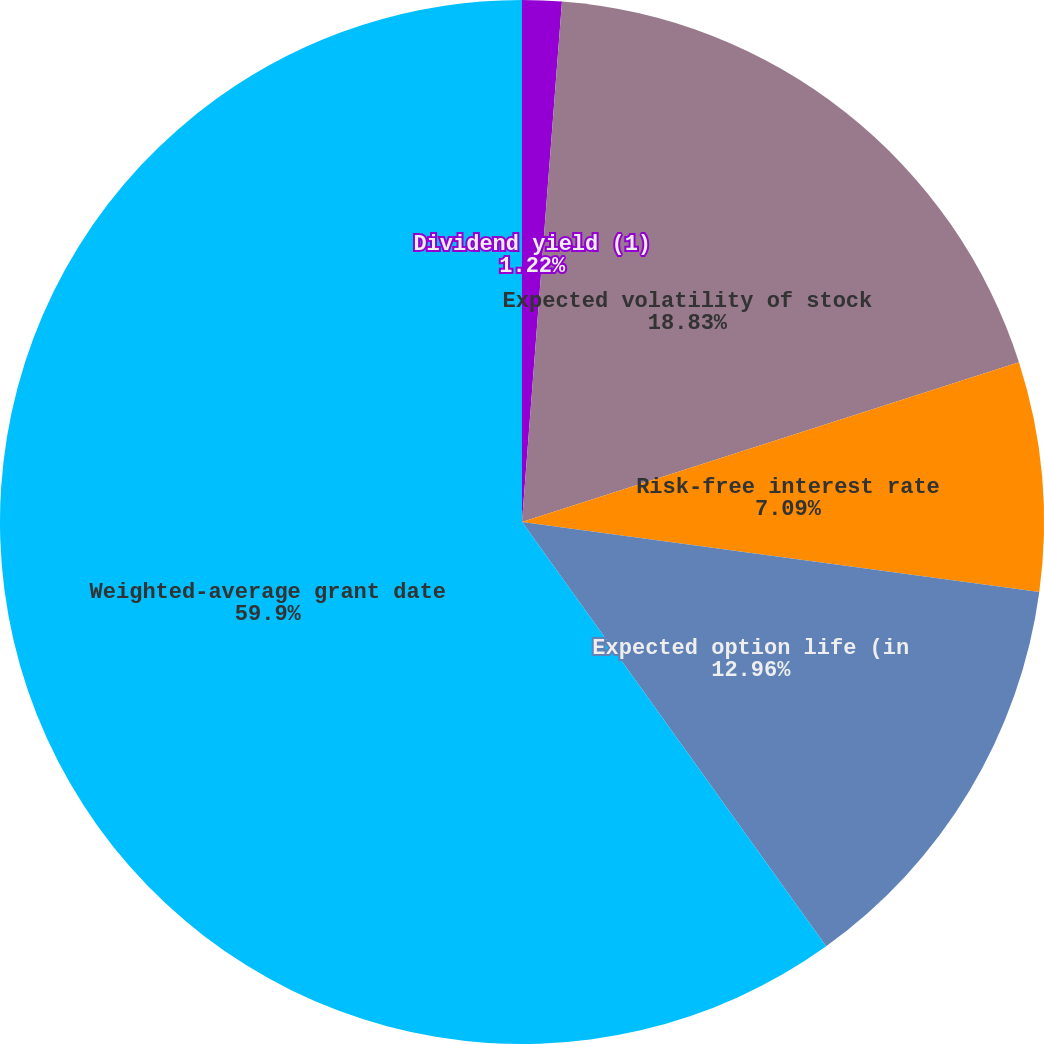Convert chart. <chart><loc_0><loc_0><loc_500><loc_500><pie_chart><fcel>Dividend yield (1)<fcel>Expected volatility of stock<fcel>Risk-free interest rate<fcel>Expected option life (in<fcel>Weighted-average grant date<nl><fcel>1.22%<fcel>18.83%<fcel>7.09%<fcel>12.96%<fcel>59.9%<nl></chart> 